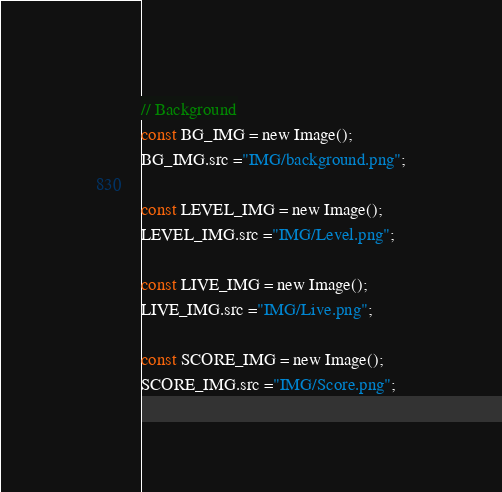<code> <loc_0><loc_0><loc_500><loc_500><_JavaScript_>
// Background
const BG_IMG = new Image();
BG_IMG.src ="IMG/background.png";

const LEVEL_IMG = new Image();
LEVEL_IMG.src ="IMG/Level.png";

const LIVE_IMG = new Image();
LIVE_IMG.src ="IMG/Live.png";

const SCORE_IMG = new Image();
SCORE_IMG.src ="IMG/Score.png";</code> 